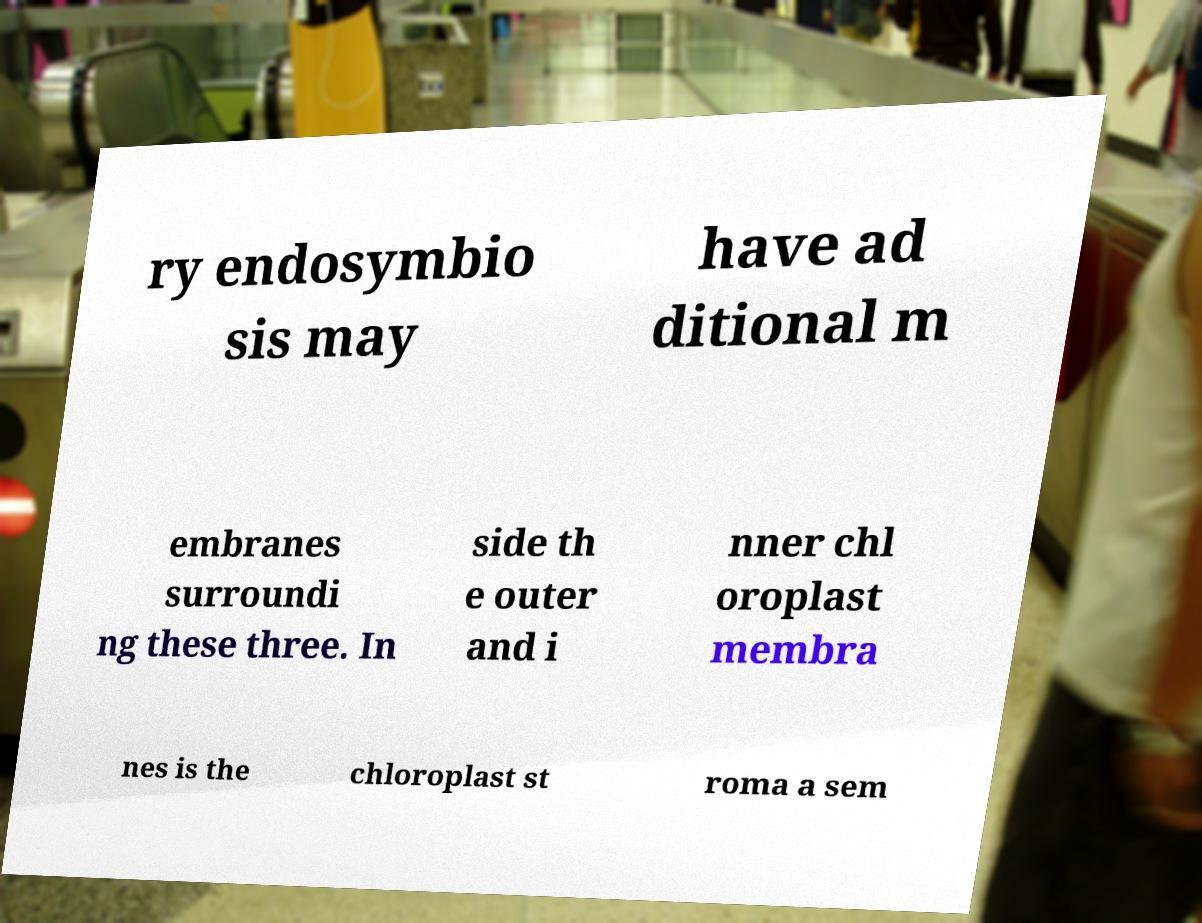Please read and relay the text visible in this image. What does it say? ry endosymbio sis may have ad ditional m embranes surroundi ng these three. In side th e outer and i nner chl oroplast membra nes is the chloroplast st roma a sem 